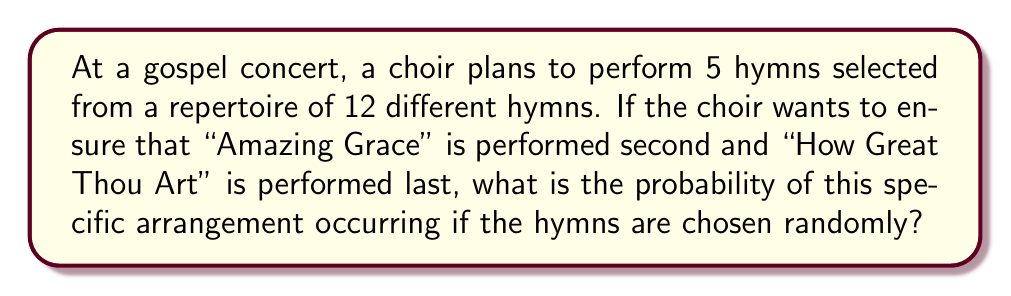Help me with this question. Let's approach this step-by-step:

1) We need to fill 5 positions in total, but two of them are already fixed:
   - "Amazing Grace" must be second
   - "How Great Thou Art" must be last

2) This leaves us with 3 positions to fill (1st, 3rd, and 4th).

3) For these 3 positions, we have 10 hymns to choose from (12 total - 2 fixed).

4) The number of ways to fill these 3 positions is a permutation:
   $P(10,3) = \frac{10!}{(10-3)!} = \frac{10!}{7!} = 720$

5) The total number of ways to arrange 5 hymns out of 12 is:
   $P(12,5) = \frac{12!}{(12-5)!} = \frac{12!}{7!} = 95,040$

6) The probability is the number of favorable outcomes divided by the total number of possible outcomes:

   $P(\text{desired arrangement}) = \frac{\text{favorable outcomes}}{\text{total outcomes}} = \frac{720}{95,040}$

7) Simplifying this fraction:
   $\frac{720}{95,040} = \frac{3}{396} = \frac{1}{132}$

Therefore, the probability of this specific arrangement occurring is $\frac{1}{132}$.
Answer: $\frac{1}{132}$ 